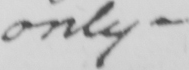What text is written in this handwritten line? only  _ 